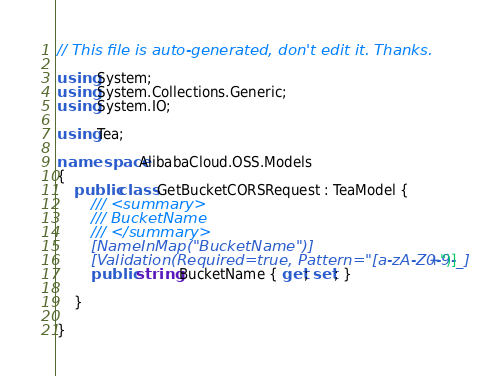Convert code to text. <code><loc_0><loc_0><loc_500><loc_500><_C#_>// This file is auto-generated, don't edit it. Thanks.

using System;
using System.Collections.Generic;
using System.IO;

using Tea;

namespace AlibabaCloud.OSS.Models
{
    public class GetBucketCORSRequest : TeaModel {
        /// <summary>
        /// BucketName
        /// </summary>
        [NameInMap("BucketName")]
        [Validation(Required=true, Pattern="[a-zA-Z0-9-_]+")]
        public string BucketName { get; set; }

    }

}
</code> 